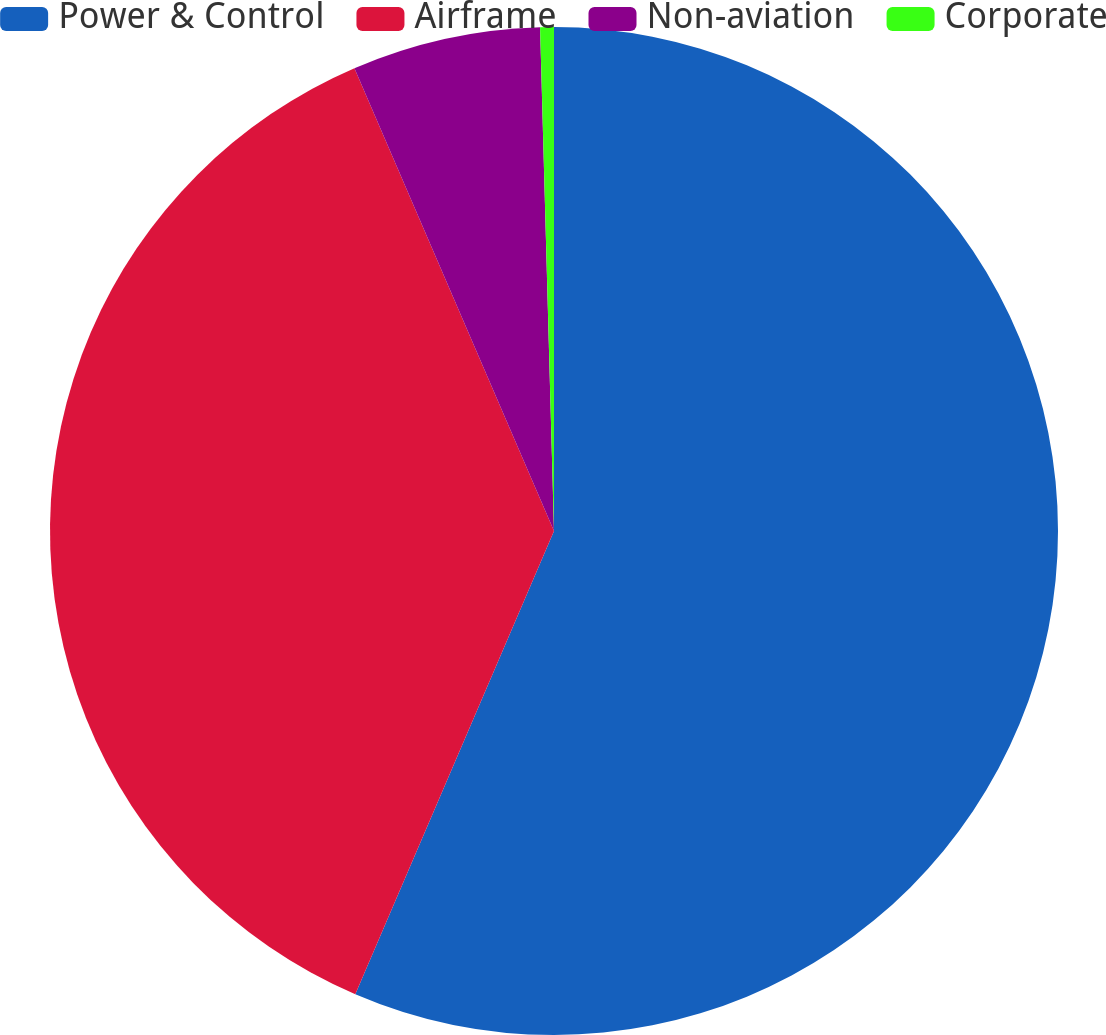Convert chart. <chart><loc_0><loc_0><loc_500><loc_500><pie_chart><fcel>Power & Control<fcel>Airframe<fcel>Non-aviation<fcel>Corporate<nl><fcel>56.45%<fcel>37.07%<fcel>6.04%<fcel>0.44%<nl></chart> 